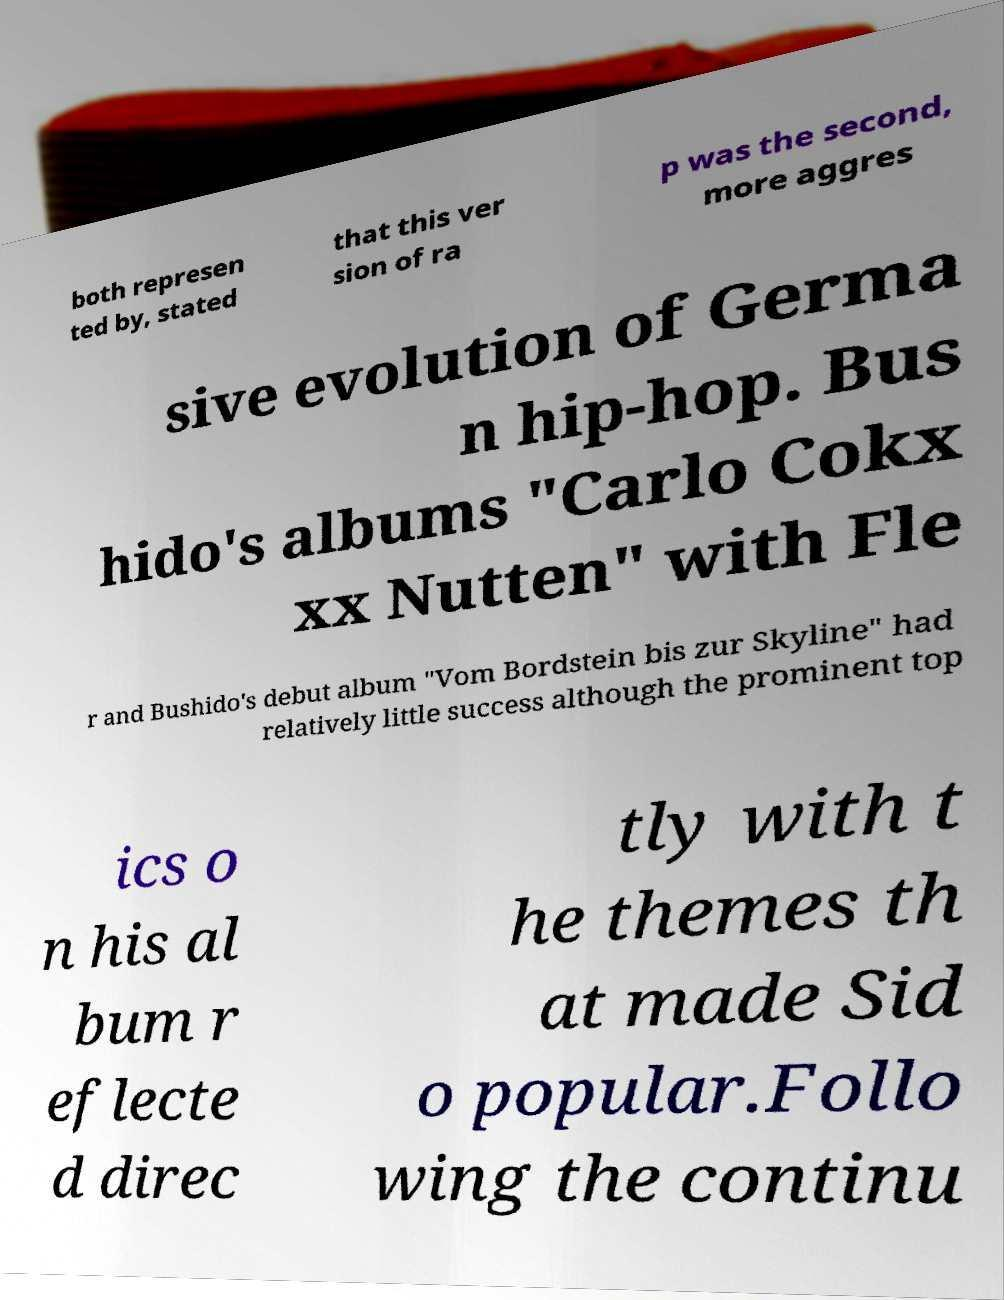For documentation purposes, I need the text within this image transcribed. Could you provide that? both represen ted by, stated that this ver sion of ra p was the second, more aggres sive evolution of Germa n hip-hop. Bus hido's albums "Carlo Cokx xx Nutten" with Fle r and Bushido's debut album "Vom Bordstein bis zur Skyline" had relatively little success although the prominent top ics o n his al bum r eflecte d direc tly with t he themes th at made Sid o popular.Follo wing the continu 